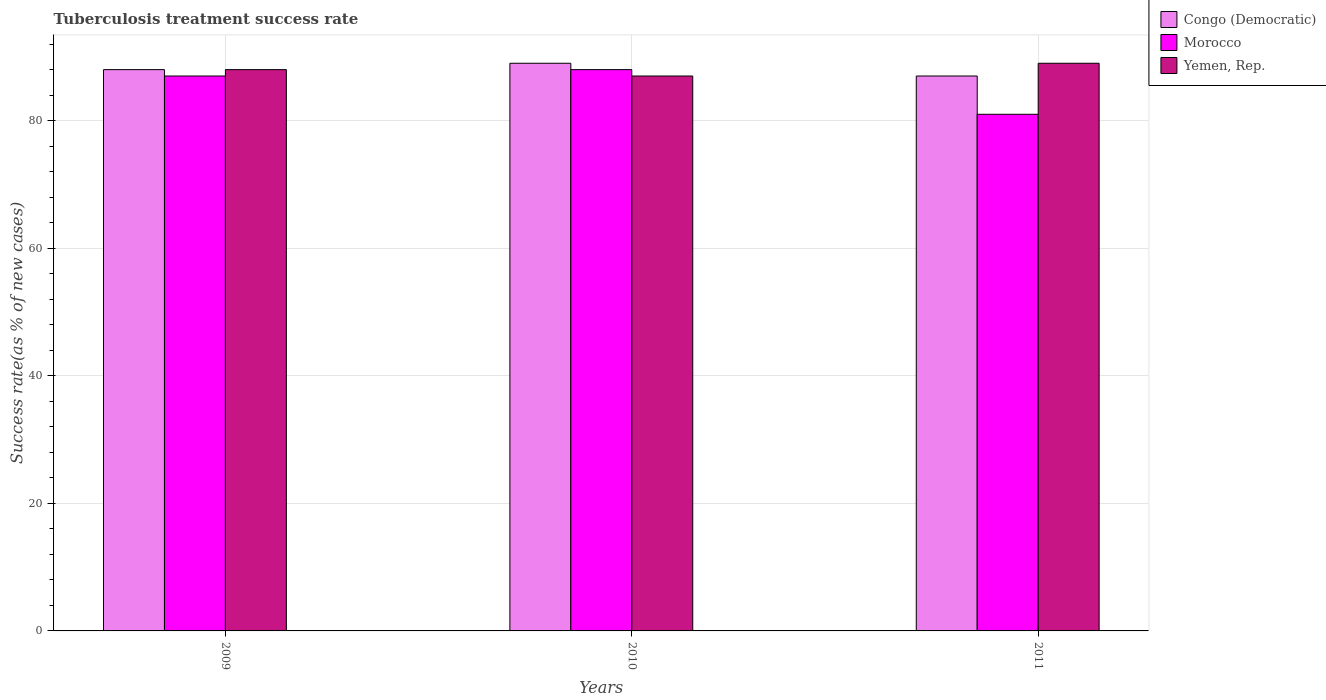How many groups of bars are there?
Give a very brief answer. 3. Are the number of bars on each tick of the X-axis equal?
Offer a terse response. Yes. In how many cases, is the number of bars for a given year not equal to the number of legend labels?
Offer a terse response. 0. What is the tuberculosis treatment success rate in Yemen, Rep. in 2011?
Provide a short and direct response. 89. Across all years, what is the maximum tuberculosis treatment success rate in Yemen, Rep.?
Ensure brevity in your answer.  89. Across all years, what is the minimum tuberculosis treatment success rate in Yemen, Rep.?
Provide a short and direct response. 87. In which year was the tuberculosis treatment success rate in Yemen, Rep. minimum?
Provide a short and direct response. 2010. What is the total tuberculosis treatment success rate in Morocco in the graph?
Give a very brief answer. 256. What is the difference between the tuberculosis treatment success rate in Congo (Democratic) in 2010 and that in 2011?
Ensure brevity in your answer.  2. What is the difference between the tuberculosis treatment success rate in Congo (Democratic) in 2010 and the tuberculosis treatment success rate in Morocco in 2009?
Ensure brevity in your answer.  2. In the year 2010, what is the difference between the tuberculosis treatment success rate in Yemen, Rep. and tuberculosis treatment success rate in Congo (Democratic)?
Your answer should be very brief. -2. What is the ratio of the tuberculosis treatment success rate in Congo (Democratic) in 2009 to that in 2011?
Give a very brief answer. 1.01. What is the difference between the highest and the second highest tuberculosis treatment success rate in Congo (Democratic)?
Make the answer very short. 1. What is the difference between the highest and the lowest tuberculosis treatment success rate in Yemen, Rep.?
Give a very brief answer. 2. What does the 1st bar from the left in 2009 represents?
Keep it short and to the point. Congo (Democratic). What does the 3rd bar from the right in 2010 represents?
Provide a short and direct response. Congo (Democratic). How many years are there in the graph?
Provide a succinct answer. 3. What is the difference between two consecutive major ticks on the Y-axis?
Offer a very short reply. 20. Does the graph contain grids?
Offer a terse response. Yes. Where does the legend appear in the graph?
Offer a very short reply. Top right. What is the title of the graph?
Offer a very short reply. Tuberculosis treatment success rate. Does "High income" appear as one of the legend labels in the graph?
Your answer should be very brief. No. What is the label or title of the X-axis?
Keep it short and to the point. Years. What is the label or title of the Y-axis?
Your answer should be compact. Success rate(as % of new cases). What is the Success rate(as % of new cases) of Congo (Democratic) in 2009?
Offer a very short reply. 88. What is the Success rate(as % of new cases) in Yemen, Rep. in 2009?
Offer a terse response. 88. What is the Success rate(as % of new cases) in Congo (Democratic) in 2010?
Ensure brevity in your answer.  89. What is the Success rate(as % of new cases) in Morocco in 2010?
Ensure brevity in your answer.  88. What is the Success rate(as % of new cases) in Congo (Democratic) in 2011?
Your response must be concise. 87. What is the Success rate(as % of new cases) of Yemen, Rep. in 2011?
Give a very brief answer. 89. Across all years, what is the maximum Success rate(as % of new cases) in Congo (Democratic)?
Keep it short and to the point. 89. Across all years, what is the maximum Success rate(as % of new cases) of Yemen, Rep.?
Provide a short and direct response. 89. Across all years, what is the minimum Success rate(as % of new cases) of Yemen, Rep.?
Give a very brief answer. 87. What is the total Success rate(as % of new cases) of Congo (Democratic) in the graph?
Ensure brevity in your answer.  264. What is the total Success rate(as % of new cases) in Morocco in the graph?
Your response must be concise. 256. What is the total Success rate(as % of new cases) of Yemen, Rep. in the graph?
Offer a terse response. 264. What is the difference between the Success rate(as % of new cases) in Congo (Democratic) in 2009 and that in 2010?
Ensure brevity in your answer.  -1. What is the difference between the Success rate(as % of new cases) of Morocco in 2009 and that in 2010?
Ensure brevity in your answer.  -1. What is the difference between the Success rate(as % of new cases) of Yemen, Rep. in 2009 and that in 2010?
Provide a succinct answer. 1. What is the difference between the Success rate(as % of new cases) of Morocco in 2009 and that in 2011?
Your answer should be very brief. 6. What is the difference between the Success rate(as % of new cases) of Congo (Democratic) in 2010 and that in 2011?
Provide a short and direct response. 2. What is the difference between the Success rate(as % of new cases) in Congo (Democratic) in 2009 and the Success rate(as % of new cases) in Yemen, Rep. in 2010?
Offer a terse response. 1. What is the difference between the Success rate(as % of new cases) in Morocco in 2009 and the Success rate(as % of new cases) in Yemen, Rep. in 2010?
Give a very brief answer. 0. What is the difference between the Success rate(as % of new cases) in Morocco in 2009 and the Success rate(as % of new cases) in Yemen, Rep. in 2011?
Offer a very short reply. -2. What is the difference between the Success rate(as % of new cases) of Congo (Democratic) in 2010 and the Success rate(as % of new cases) of Morocco in 2011?
Give a very brief answer. 8. What is the difference between the Success rate(as % of new cases) in Congo (Democratic) in 2010 and the Success rate(as % of new cases) in Yemen, Rep. in 2011?
Your response must be concise. 0. What is the average Success rate(as % of new cases) in Morocco per year?
Your response must be concise. 85.33. What is the average Success rate(as % of new cases) of Yemen, Rep. per year?
Offer a very short reply. 88. In the year 2009, what is the difference between the Success rate(as % of new cases) of Congo (Democratic) and Success rate(as % of new cases) of Yemen, Rep.?
Give a very brief answer. 0. In the year 2010, what is the difference between the Success rate(as % of new cases) in Congo (Democratic) and Success rate(as % of new cases) in Morocco?
Keep it short and to the point. 1. In the year 2010, what is the difference between the Success rate(as % of new cases) of Morocco and Success rate(as % of new cases) of Yemen, Rep.?
Ensure brevity in your answer.  1. In the year 2011, what is the difference between the Success rate(as % of new cases) of Congo (Democratic) and Success rate(as % of new cases) of Yemen, Rep.?
Give a very brief answer. -2. In the year 2011, what is the difference between the Success rate(as % of new cases) in Morocco and Success rate(as % of new cases) in Yemen, Rep.?
Provide a succinct answer. -8. What is the ratio of the Success rate(as % of new cases) in Morocco in 2009 to that in 2010?
Keep it short and to the point. 0.99. What is the ratio of the Success rate(as % of new cases) in Yemen, Rep. in 2009 to that in 2010?
Make the answer very short. 1.01. What is the ratio of the Success rate(as % of new cases) of Congo (Democratic) in 2009 to that in 2011?
Your answer should be compact. 1.01. What is the ratio of the Success rate(as % of new cases) of Morocco in 2009 to that in 2011?
Provide a succinct answer. 1.07. What is the ratio of the Success rate(as % of new cases) of Yemen, Rep. in 2009 to that in 2011?
Give a very brief answer. 0.99. What is the ratio of the Success rate(as % of new cases) in Congo (Democratic) in 2010 to that in 2011?
Your response must be concise. 1.02. What is the ratio of the Success rate(as % of new cases) of Morocco in 2010 to that in 2011?
Keep it short and to the point. 1.09. What is the ratio of the Success rate(as % of new cases) in Yemen, Rep. in 2010 to that in 2011?
Offer a very short reply. 0.98. What is the difference between the highest and the second highest Success rate(as % of new cases) in Morocco?
Provide a succinct answer. 1. What is the difference between the highest and the lowest Success rate(as % of new cases) in Morocco?
Your answer should be compact. 7. What is the difference between the highest and the lowest Success rate(as % of new cases) in Yemen, Rep.?
Your answer should be very brief. 2. 